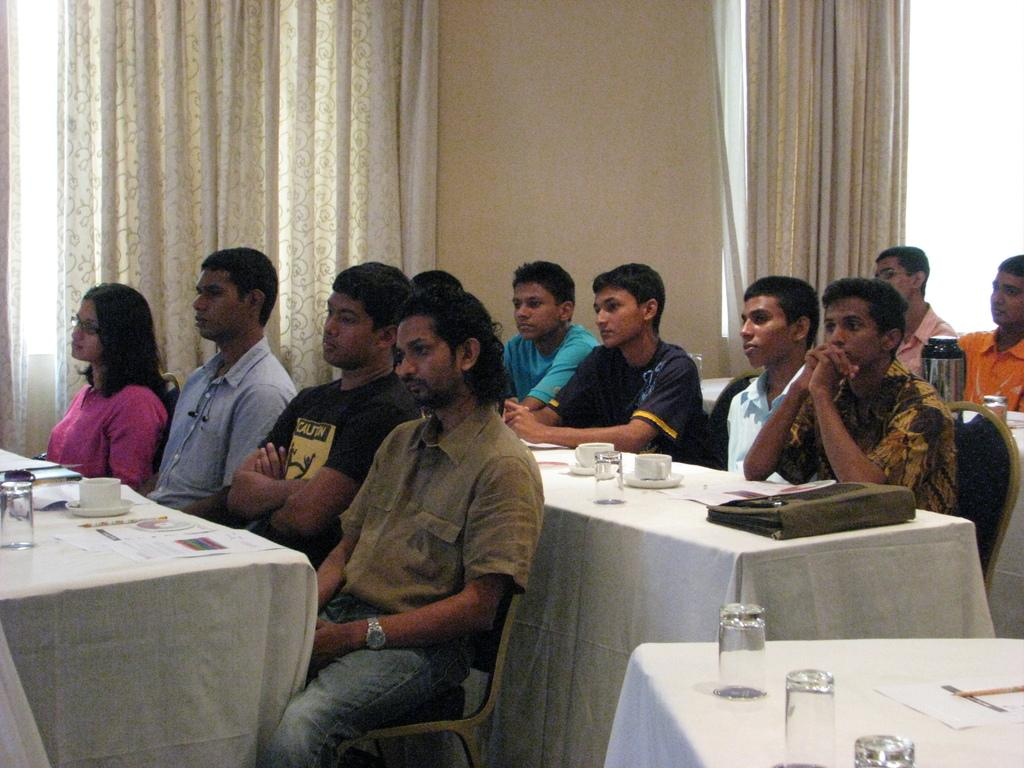How many people are in the image? There is a group of people in the image. What are the people doing in the image? The people are sitting on chairs. What objects are in front of the chairs? There are tables in front of the chairs. What items can be seen on the tables? There are glasses, cups, and papers on the tables. What type of toy is being played with by the people in the image? There is no toy present in the image; the people are sitting on chairs with tables in front of them. 